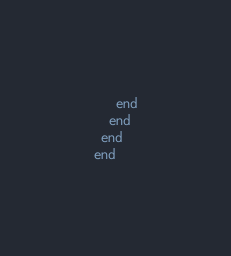<code> <loc_0><loc_0><loc_500><loc_500><_Ruby_>      end
    end
  end
end
</code> 